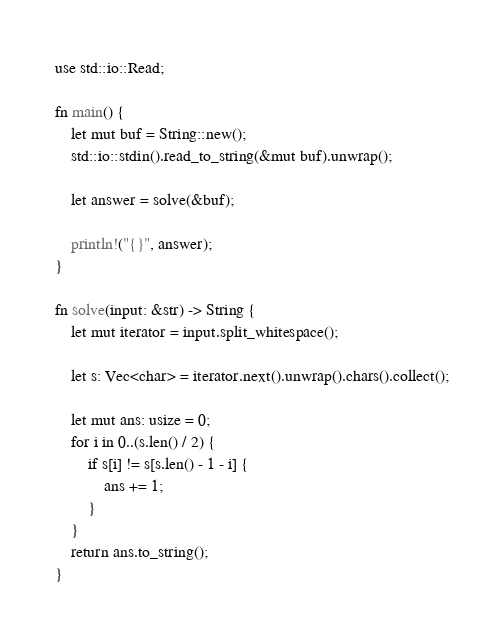Convert code to text. <code><loc_0><loc_0><loc_500><loc_500><_Rust_>use std::io::Read;

fn main() {
    let mut buf = String::new();
    std::io::stdin().read_to_string(&mut buf).unwrap();

    let answer = solve(&buf);

    println!("{}", answer);
}

fn solve(input: &str) -> String {
    let mut iterator = input.split_whitespace();

    let s: Vec<char> = iterator.next().unwrap().chars().collect();

    let mut ans: usize = 0;
    for i in 0..(s.len() / 2) {
        if s[i] != s[s.len() - 1 - i] {
            ans += 1;
        }
    }
    return ans.to_string();
}
</code> 